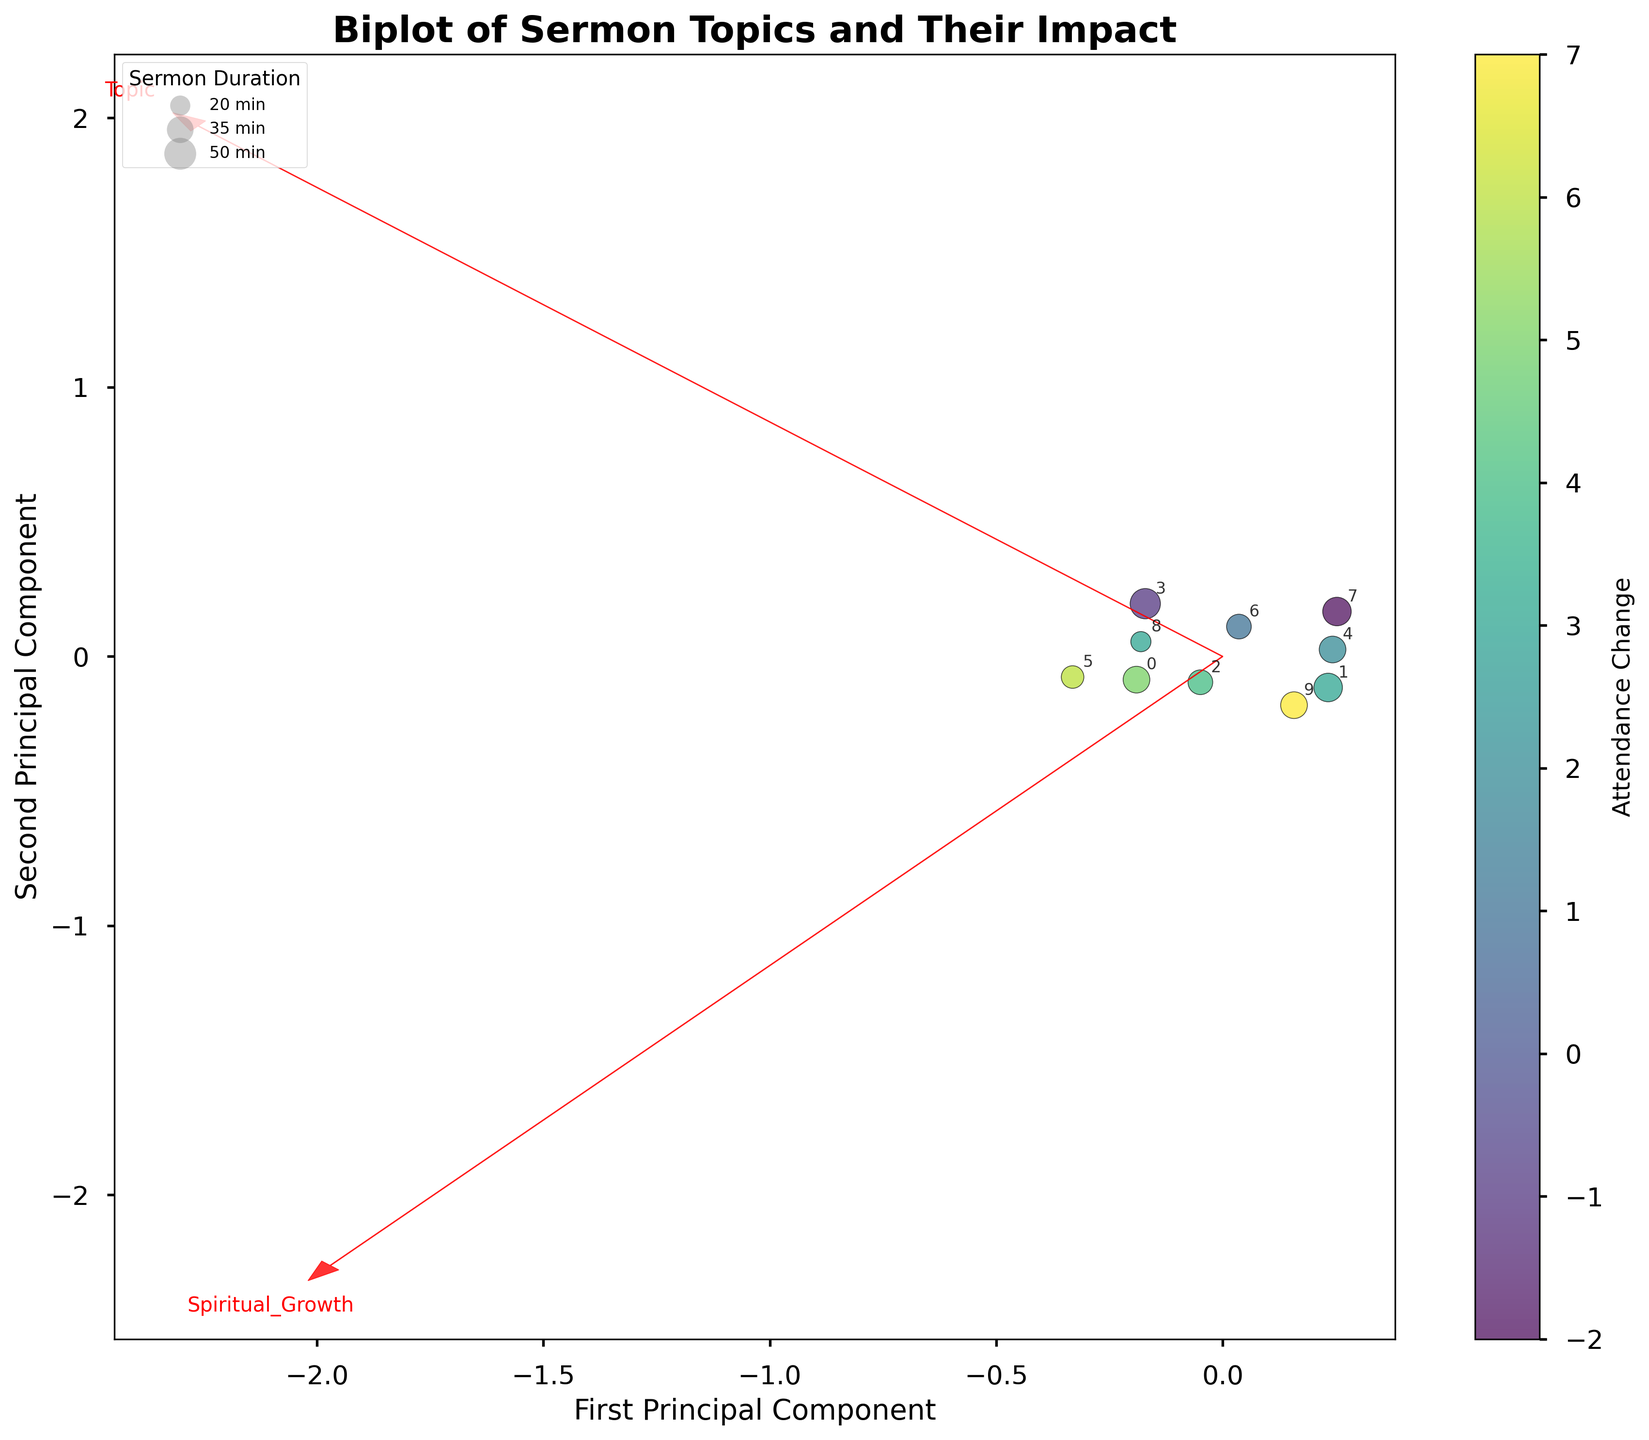What's the title of the figure? The title is typically displayed at the top of the plot. In this case, it would read off the title specified in the code.
Answer: Biplot of Sermon Topics and Their Impact How many principal components are displayed on the plot? The figure shows two principal components, as indicated by the x-axis and y-axis labels and the use of dotted arrows to represent feature vectors.
Answer: Two What is represented by the color of the data points? The color of the data points represents attendance change, as shown by the color bar on the right side of the figure.
Answer: Attendance Change Which sermon topic has the highest impact on both spiritual growth and community involvement? The sermon topic is represented by the data point in the top-right quadrant of the plot. Look for the point with high values on both axes.
Answer: Prayer and Meditation Which topics had a negative impact on attendance change? Check the color of the data points; a darker hue indicates a negative change in attendance, as seen in the color bar.
Answer: Biblical Prophecy, Interfaith Dialogue What does the size of the data points represent? According to the legend in the figure, the size of the data points represents the duration of the sermon.
Answer: Sermon Duration Which sermon topic had the highest attendance change? The topic with the lightest color (brightest hue) represents the highest attendance change, based on the color bar.
Answer: Community Service How do the features 'Spiritual Growth' and 'Community Involvement' relate to the principal components? Look at the red feature vectors (arrows) to see how they align with the principal components. The direction and length of the arrows indicate how much each original feature contributes to each principal component.
Answer: Spiritual Growth and Community Involvement both contribute to the first principal component What's the approximate duration of the 'Environmental Stewardship' sermon? Locate the data point labeled 'Environmental Stewardship' and compare its size to the legend entries.
Answer: Approximately 40 minutes Which principal component explains more variance in the data? This involves comparing the spread of the data points along the principal components. The axis with the more spread out data typically explains more variance.
Answer: First Principal Component 